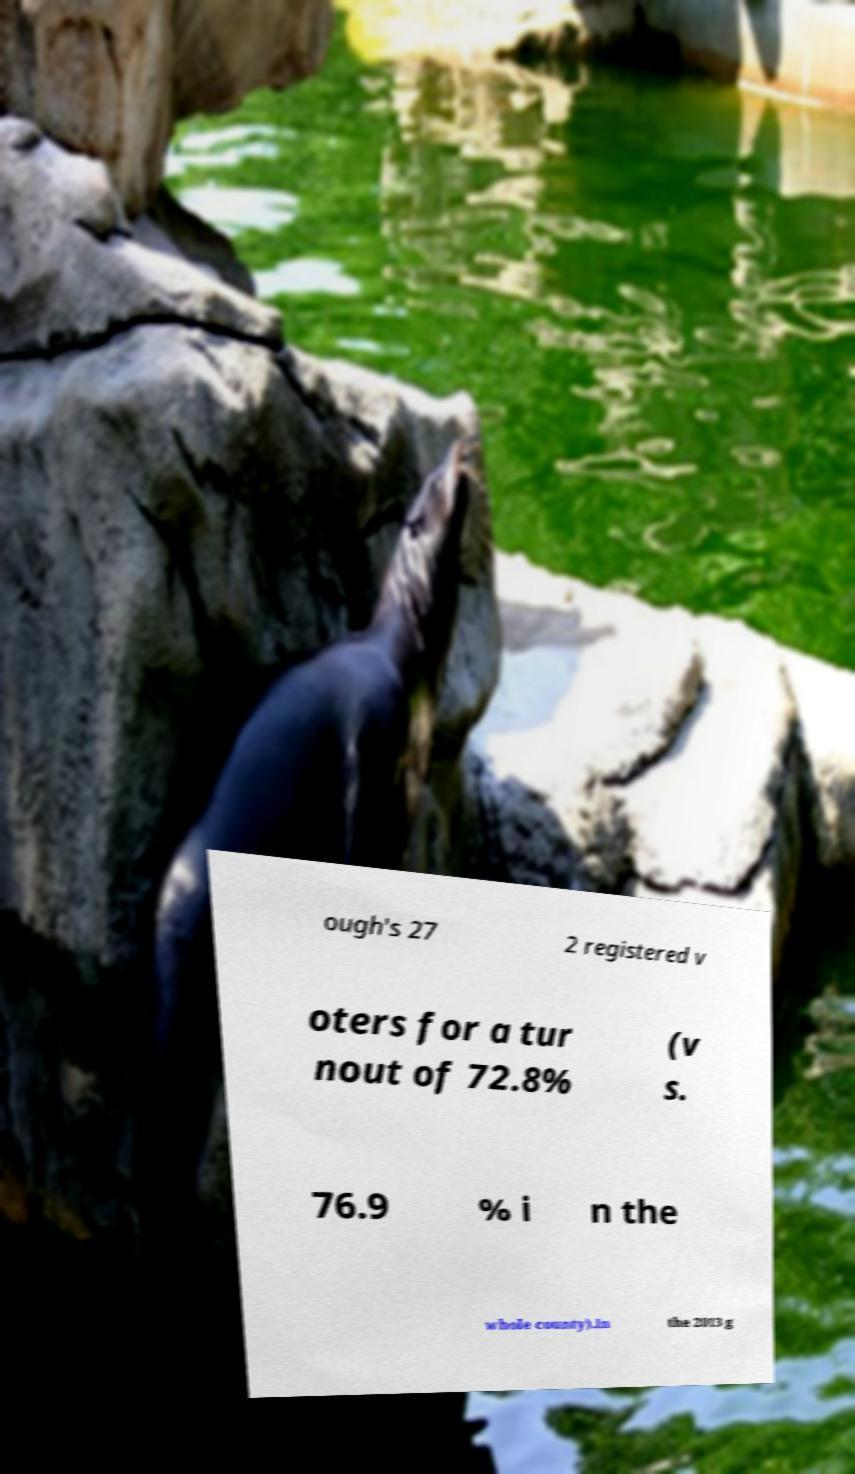Please identify and transcribe the text found in this image. ough's 27 2 registered v oters for a tur nout of 72.8% (v s. 76.9 % i n the whole county).In the 2013 g 